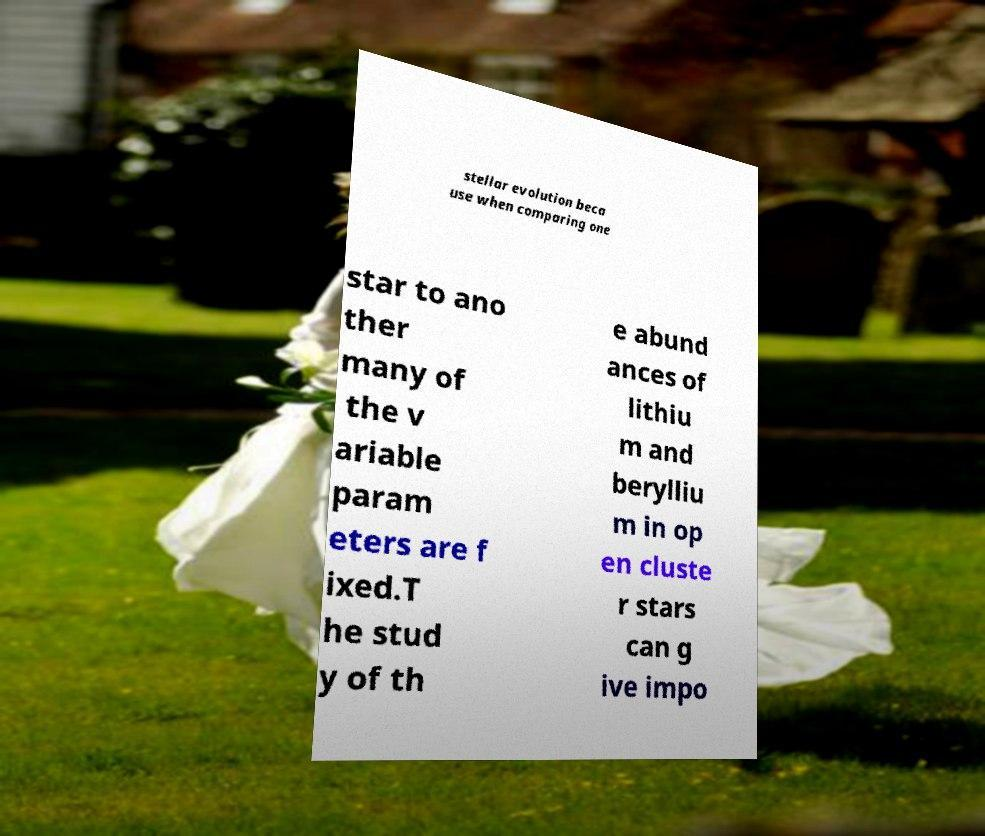Please identify and transcribe the text found in this image. stellar evolution beca use when comparing one star to ano ther many of the v ariable param eters are f ixed.T he stud y of th e abund ances of lithiu m and berylliu m in op en cluste r stars can g ive impo 